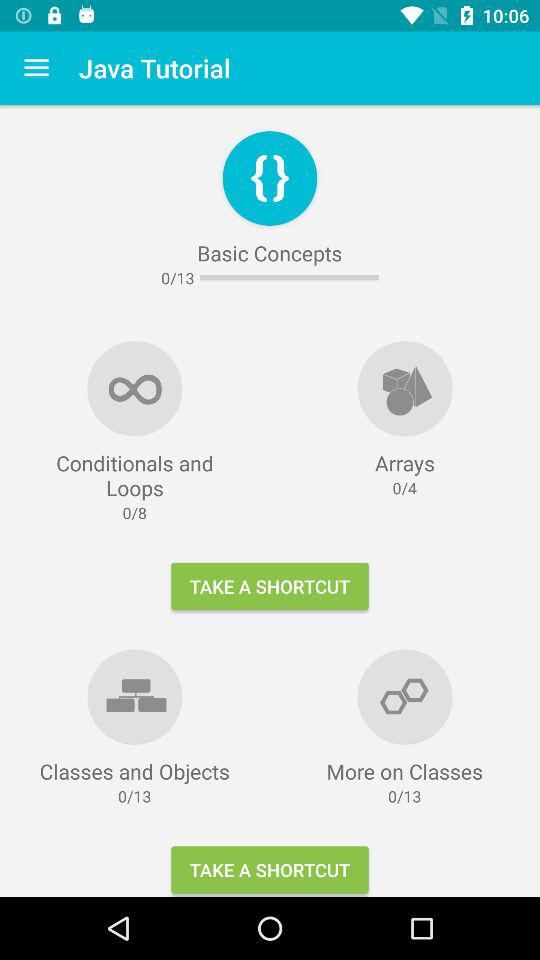How many more lessons are there in the 'Classes and Objects' section than the 'Conditionals and Loops' section?
Answer the question using a single word or phrase. 5 